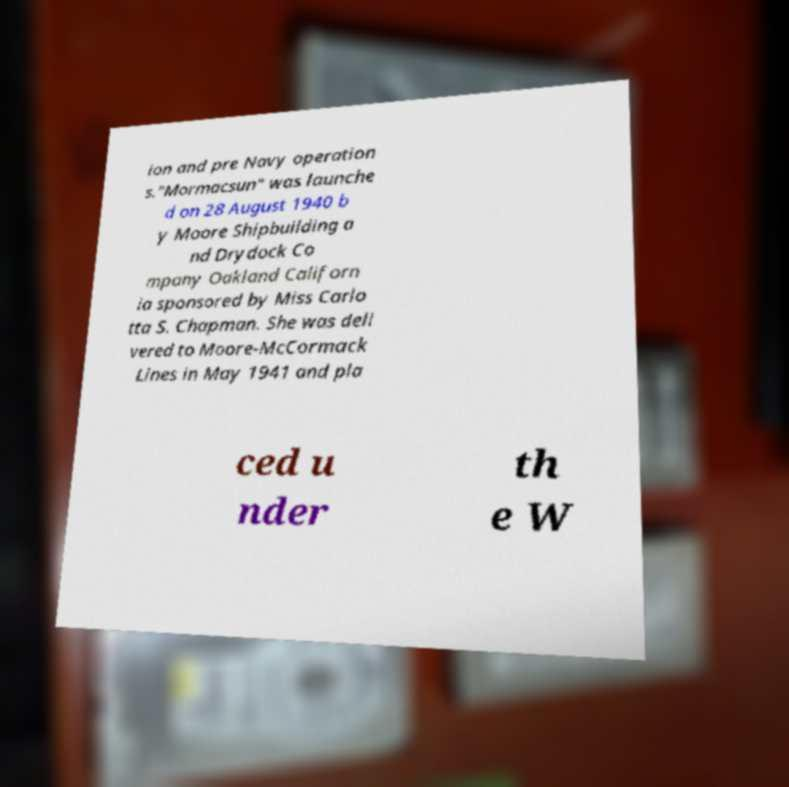For documentation purposes, I need the text within this image transcribed. Could you provide that? ion and pre Navy operation s."Mormacsun" was launche d on 28 August 1940 b y Moore Shipbuilding a nd Drydock Co mpany Oakland Californ ia sponsored by Miss Carlo tta S. Chapman. She was deli vered to Moore-McCormack Lines in May 1941 and pla ced u nder th e W 